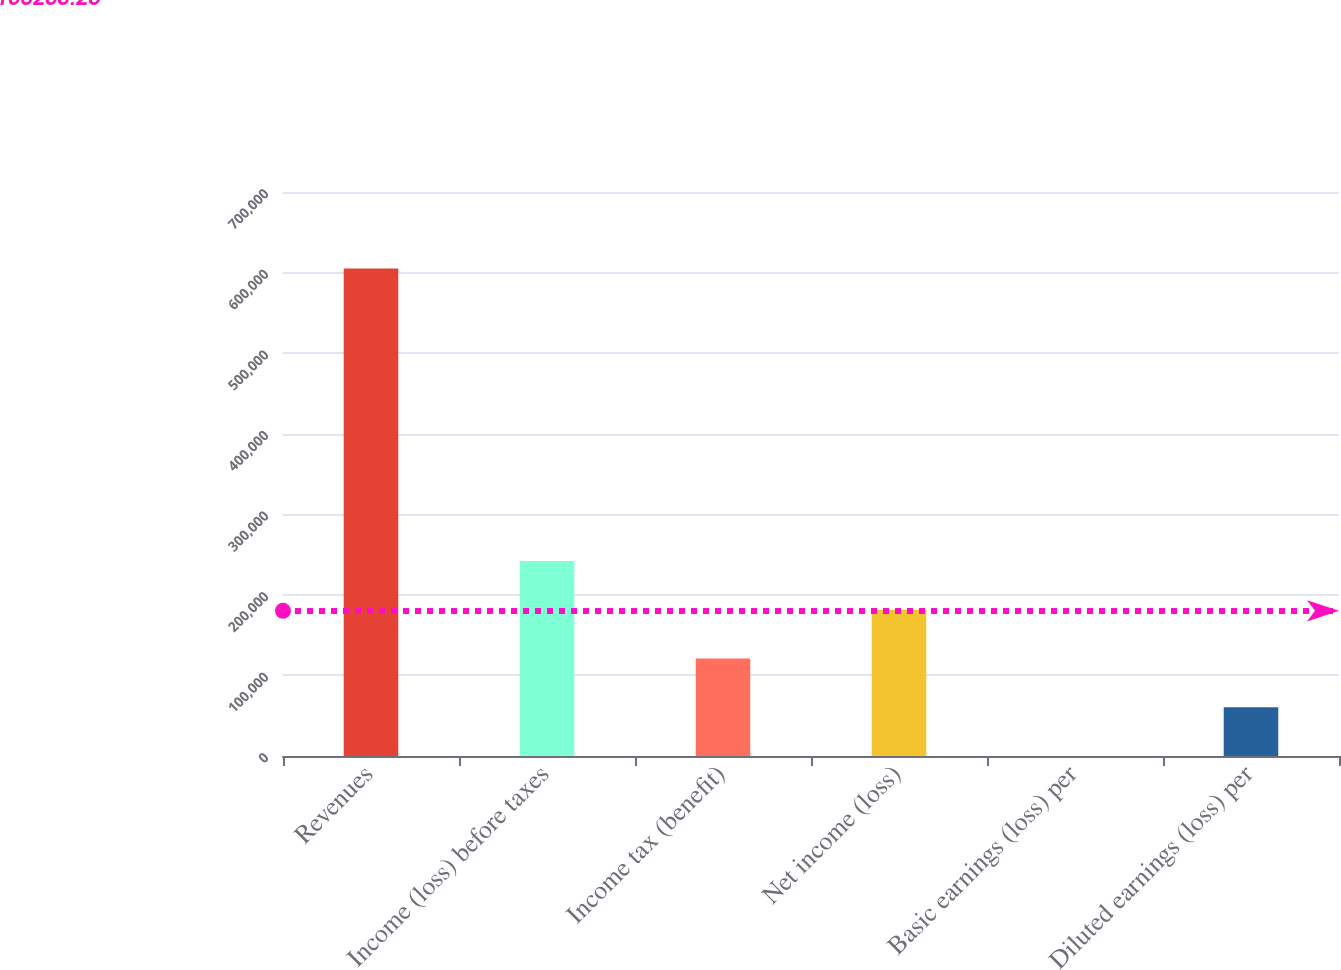<chart> <loc_0><loc_0><loc_500><loc_500><bar_chart><fcel>Revenues<fcel>Income (loss) before taxes<fcel>Income tax (benefit)<fcel>Net income (loss)<fcel>Basic earnings (loss) per<fcel>Diluted earnings (loss) per<nl><fcel>605043<fcel>242017<fcel>121009<fcel>181513<fcel>0.25<fcel>60504.5<nl></chart> 